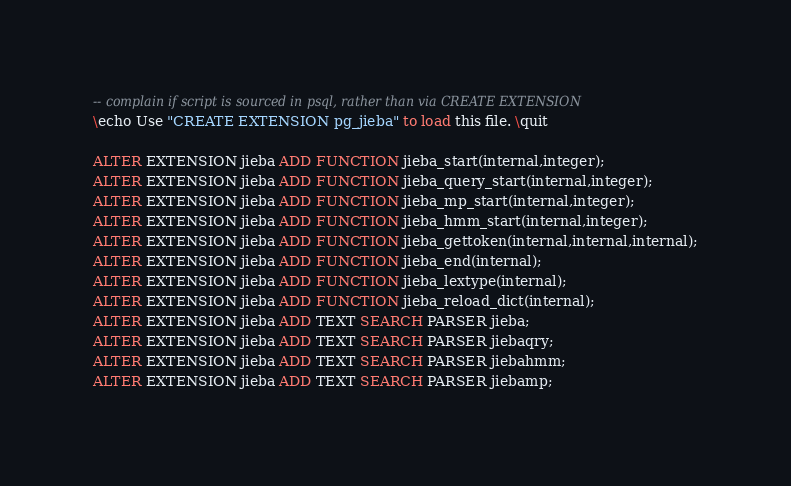Convert code to text. <code><loc_0><loc_0><loc_500><loc_500><_SQL_>-- complain if script is sourced in psql, rather than via CREATE EXTENSION
\echo Use "CREATE EXTENSION pg_jieba" to load this file. \quit

ALTER EXTENSION jieba ADD FUNCTION jieba_start(internal,integer);
ALTER EXTENSION jieba ADD FUNCTION jieba_query_start(internal,integer);
ALTER EXTENSION jieba ADD FUNCTION jieba_mp_start(internal,integer);
ALTER EXTENSION jieba ADD FUNCTION jieba_hmm_start(internal,integer);
ALTER EXTENSION jieba ADD FUNCTION jieba_gettoken(internal,internal,internal);
ALTER EXTENSION jieba ADD FUNCTION jieba_end(internal);
ALTER EXTENSION jieba ADD FUNCTION jieba_lextype(internal);
ALTER EXTENSION jieba ADD FUNCTION jieba_reload_dict(internal);
ALTER EXTENSION jieba ADD TEXT SEARCH PARSER jieba;
ALTER EXTENSION jieba ADD TEXT SEARCH PARSER jiebaqry;
ALTER EXTENSION jieba ADD TEXT SEARCH PARSER jiebahmm;
ALTER EXTENSION jieba ADD TEXT SEARCH PARSER jiebamp;
</code> 